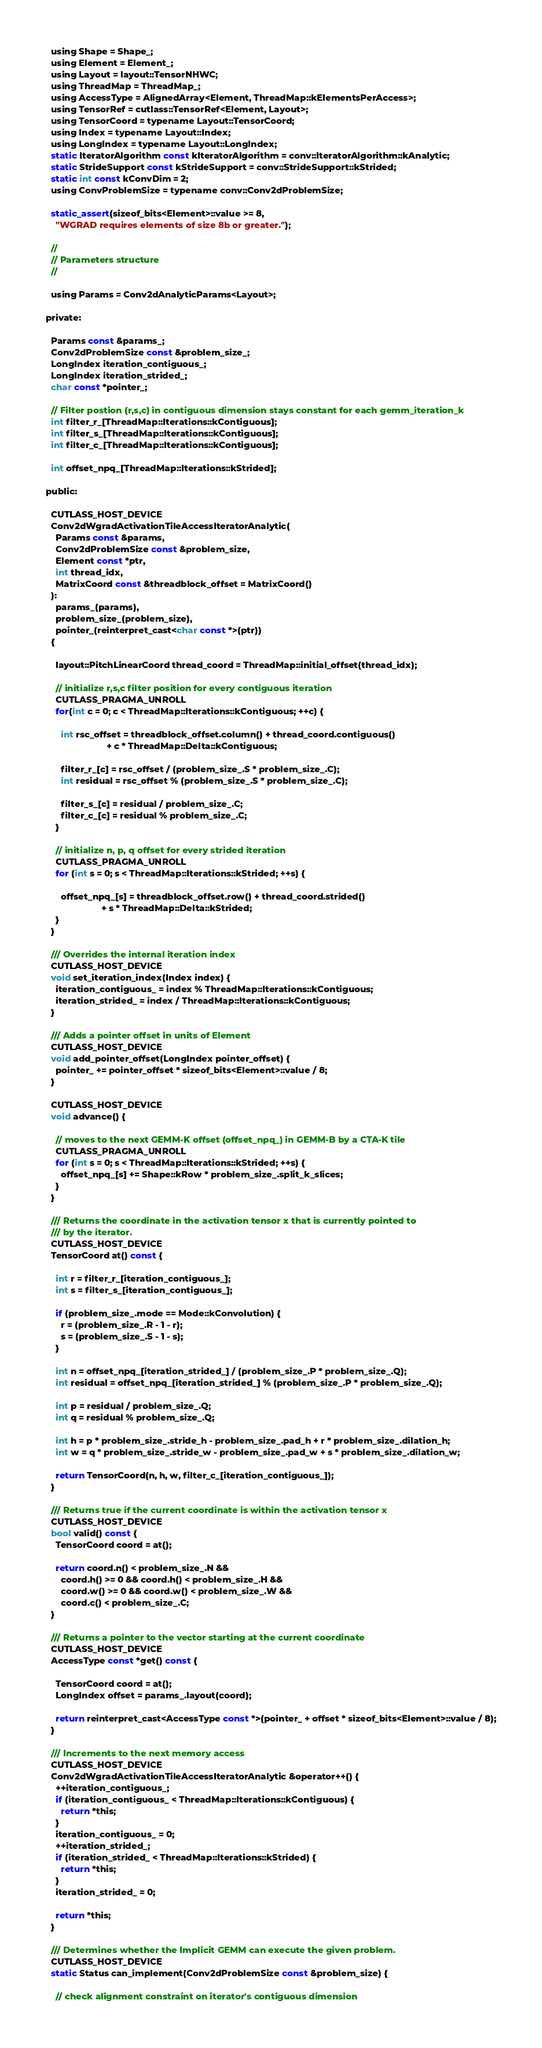Convert code to text. <code><loc_0><loc_0><loc_500><loc_500><_C_>  using Shape = Shape_;
  using Element = Element_;
  using Layout = layout::TensorNHWC;
  using ThreadMap = ThreadMap_;
  using AccessType = AlignedArray<Element, ThreadMap::kElementsPerAccess>;
  using TensorRef = cutlass::TensorRef<Element, Layout>;
  using TensorCoord = typename Layout::TensorCoord;
  using Index = typename Layout::Index;
  using LongIndex = typename Layout::LongIndex;
  static IteratorAlgorithm const kIteratorAlgorithm = conv::IteratorAlgorithm::kAnalytic;
  static StrideSupport const kStrideSupport = conv::StrideSupport::kStrided;
  static int const kConvDim = 2;
  using ConvProblemSize = typename conv::Conv2dProblemSize;
  
  static_assert(sizeof_bits<Element>::value >= 8,
    "WGRAD requires elements of size 8b or greater.");

  //
  // Parameters structure
  //

  using Params = Conv2dAnalyticParams<Layout>;

private:

  Params const &params_;
  Conv2dProblemSize const &problem_size_;
  LongIndex iteration_contiguous_;
  LongIndex iteration_strided_;
  char const *pointer_;

  // Filter postion (r,s,c) in contiguous dimension stays constant for each gemm_iteration_k
  int filter_r_[ThreadMap::Iterations::kContiguous];
  int filter_s_[ThreadMap::Iterations::kContiguous];
  int filter_c_[ThreadMap::Iterations::kContiguous];

  int offset_npq_[ThreadMap::Iterations::kStrided];

public:

  CUTLASS_HOST_DEVICE
  Conv2dWgradActivationTileAccessIteratorAnalytic(
    Params const &params, 
    Conv2dProblemSize const &problem_size,
    Element const *ptr,
    int thread_idx,
    MatrixCoord const &threadblock_offset = MatrixCoord()
  ):
    params_(params), 
    problem_size_(problem_size), 
    pointer_(reinterpret_cast<char const *>(ptr))
  {

    layout::PitchLinearCoord thread_coord = ThreadMap::initial_offset(thread_idx);
    
    // initialize r,s,c filter position for every contiguous iteration
    CUTLASS_PRAGMA_UNROLL
    for(int c = 0; c < ThreadMap::Iterations::kContiguous; ++c) {

      int rsc_offset = threadblock_offset.column() + thread_coord.contiguous()
                        + c * ThreadMap::Delta::kContiguous;

      filter_r_[c] = rsc_offset / (problem_size_.S * problem_size_.C);
      int residual = rsc_offset % (problem_size_.S * problem_size_.C);

      filter_s_[c] = residual / problem_size_.C;
      filter_c_[c] = residual % problem_size_.C;
    }

    // initialize n, p, q offset for every strided iteration
    CUTLASS_PRAGMA_UNROLL
    for (int s = 0; s < ThreadMap::Iterations::kStrided; ++s) {
    
      offset_npq_[s] = threadblock_offset.row() + thread_coord.strided() 
                      + s * ThreadMap::Delta::kStrided;   
    }
  }

  /// Overrides the internal iteration index
  CUTLASS_HOST_DEVICE
  void set_iteration_index(Index index) {
    iteration_contiguous_ = index % ThreadMap::Iterations::kContiguous;
    iteration_strided_ = index / ThreadMap::Iterations::kContiguous;
  }

  /// Adds a pointer offset in units of Element
  CUTLASS_HOST_DEVICE
  void add_pointer_offset(LongIndex pointer_offset) {
    pointer_ += pointer_offset * sizeof_bits<Element>::value / 8;
  }

  CUTLASS_HOST_DEVICE
  void advance() {
    
    // moves to the next GEMM-K offset (offset_npq_) in GEMM-B by a CTA-K tile
    CUTLASS_PRAGMA_UNROLL
    for (int s = 0; s < ThreadMap::Iterations::kStrided; ++s) {
      offset_npq_[s] += Shape::kRow * problem_size_.split_k_slices;
    }
  }

  /// Returns the coordinate in the activation tensor x that is currently pointed to
  /// by the iterator.
  CUTLASS_HOST_DEVICE
  TensorCoord at() const {

    int r = filter_r_[iteration_contiguous_];
    int s = filter_s_[iteration_contiguous_];

    if (problem_size_.mode == Mode::kConvolution) {
      r = (problem_size_.R - 1 - r);
      s = (problem_size_.S - 1 - s);
    }

    int n = offset_npq_[iteration_strided_] / (problem_size_.P * problem_size_.Q);
    int residual = offset_npq_[iteration_strided_] % (problem_size_.P * problem_size_.Q);
   
    int p = residual / problem_size_.Q;
    int q = residual % problem_size_.Q;
 
    int h = p * problem_size_.stride_h - problem_size_.pad_h + r * problem_size_.dilation_h;
    int w = q * problem_size_.stride_w - problem_size_.pad_w + s * problem_size_.dilation_w;

    return TensorCoord(n, h, w, filter_c_[iteration_contiguous_]);
  }

  /// Returns true if the current coordinate is within the activation tensor x
  CUTLASS_HOST_DEVICE
  bool valid() const {
    TensorCoord coord = at();

    return coord.n() < problem_size_.N &&
      coord.h() >= 0 && coord.h() < problem_size_.H &&
      coord.w() >= 0 && coord.w() < problem_size_.W &&
      coord.c() < problem_size_.C;
  }

  /// Returns a pointer to the vector starting at the current coordinate
  CUTLASS_HOST_DEVICE
  AccessType const *get() const {

    TensorCoord coord = at();
    LongIndex offset = params_.layout(coord);

    return reinterpret_cast<AccessType const *>(pointer_ + offset * sizeof_bits<Element>::value / 8);
  }

  /// Increments to the next memory access
  CUTLASS_HOST_DEVICE
  Conv2dWgradActivationTileAccessIteratorAnalytic &operator++() {
    ++iteration_contiguous_;
    if (iteration_contiguous_ < ThreadMap::Iterations::kContiguous) {
      return *this;
    }
    iteration_contiguous_ = 0;
    ++iteration_strided_;
    if (iteration_strided_ < ThreadMap::Iterations::kStrided) {
      return *this;
    }
    iteration_strided_ = 0;
 
    return *this;
  }

  /// Determines whether the Implicit GEMM can execute the given problem.
  CUTLASS_HOST_DEVICE
  static Status can_implement(Conv2dProblemSize const &problem_size) {

    // check alignment constraint on iterator's contiguous dimension</code> 